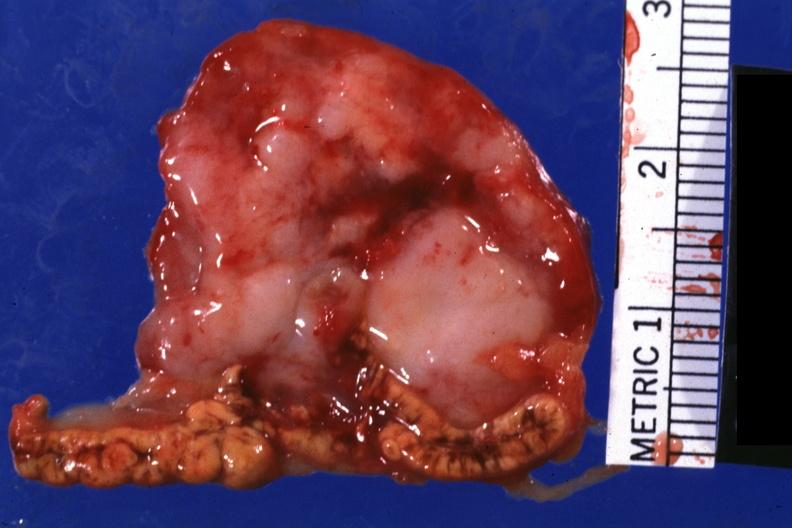what is present?
Answer the question using a single word or phrase. Metastatic carcinoma 